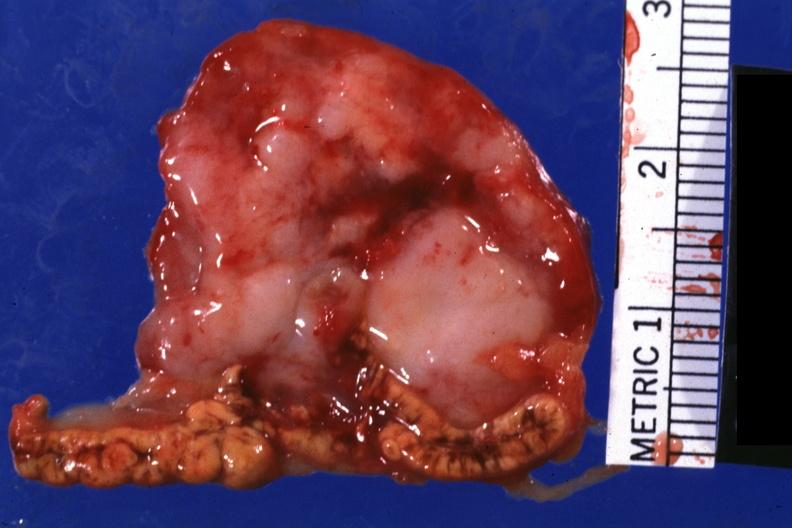what is present?
Answer the question using a single word or phrase. Metastatic carcinoma 